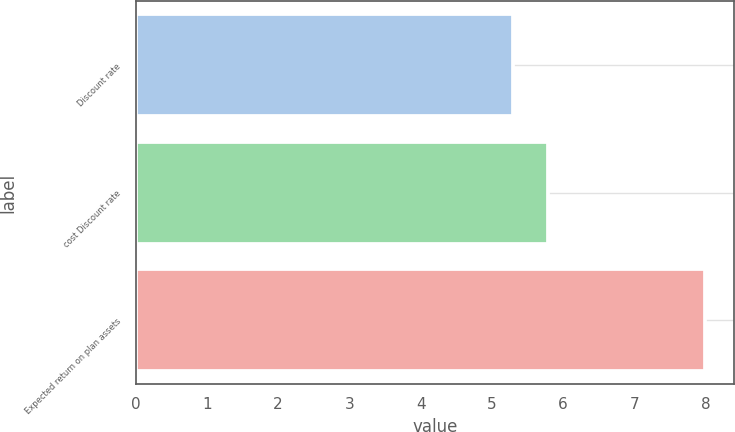<chart> <loc_0><loc_0><loc_500><loc_500><bar_chart><fcel>Discount rate<fcel>cost Discount rate<fcel>Expected return on plan assets<nl><fcel>5.3<fcel>5.79<fcel>8<nl></chart> 